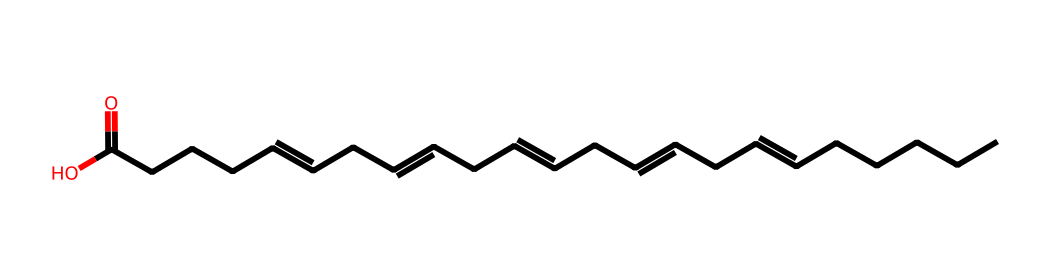What type of fatty acid is represented by this structure? The structure contains multiple double bonds, indicating it is a polyunsaturated fatty acid.
Answer: polyunsaturated fatty acid How many double bonds are present in this chemical? The SMILES notation shows four double bonds between carbon atoms, as indicated by the '=' symbols.
Answer: four What functional group is present at the end of this molecule? The notation includes "C(=O)O," indicating that there is a carboxylic acid functional group at the end of the fatty acid chain.
Answer: carboxylic acid What is the main type of lipid this structure represents? Given that this is a long-chain fatty acid with multiple double bonds, it is classified as an omega-3 fatty acid specifically.
Answer: omega-3 fatty acid What is the general effect of omega-3 fatty acids on joint health? Omega-3 fatty acids are known to reduce inflammation, which is beneficial for joint health and can aid in rehabilitation.
Answer: reduce inflammation 